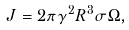Convert formula to latex. <formula><loc_0><loc_0><loc_500><loc_500>J = 2 \pi \gamma ^ { 2 } R ^ { 3 } \sigma \Omega ,</formula> 